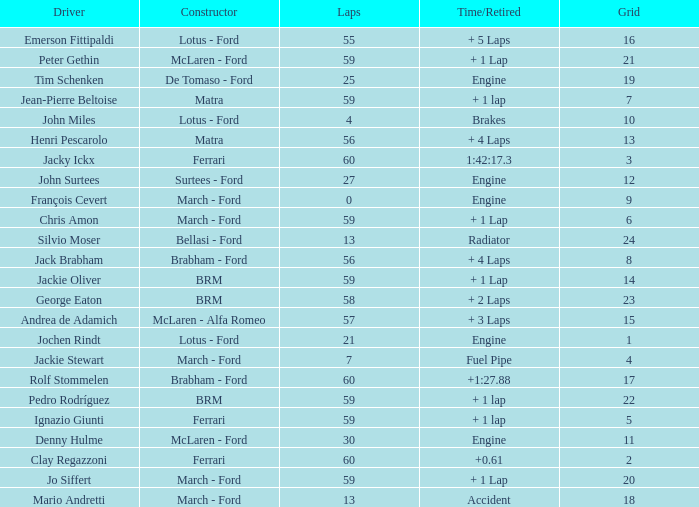I want the driver for grid of 9 François Cevert. 